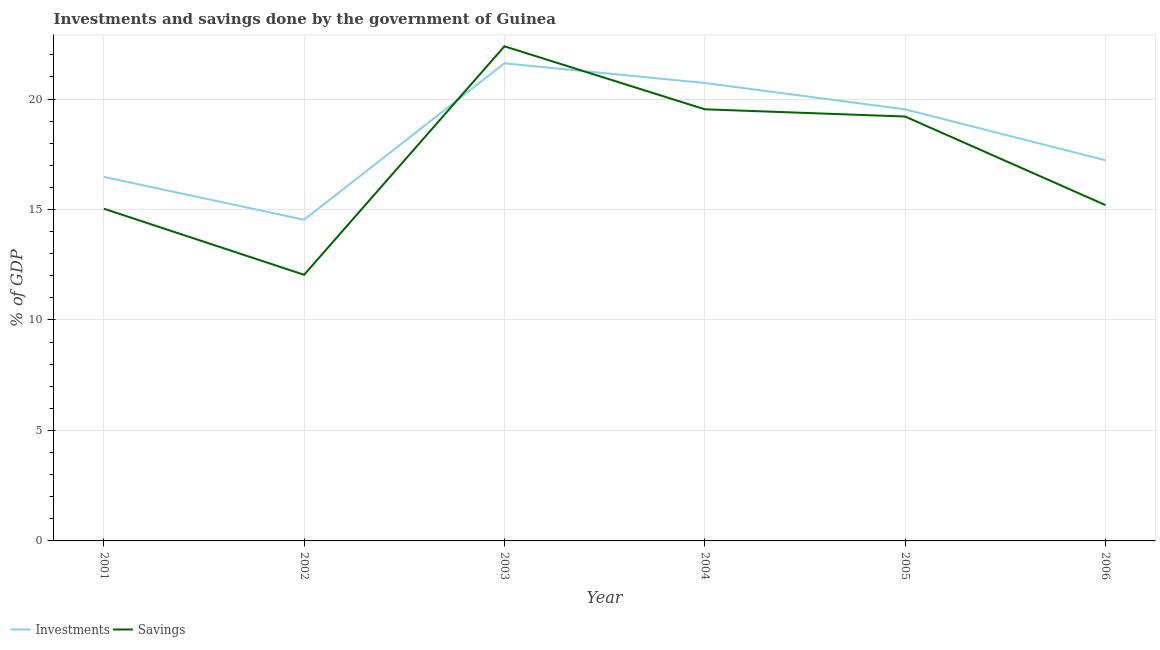How many different coloured lines are there?
Offer a very short reply. 2. What is the investments of government in 2005?
Your response must be concise. 19.53. Across all years, what is the maximum investments of government?
Make the answer very short. 21.62. Across all years, what is the minimum savings of government?
Provide a succinct answer. 12.05. In which year was the savings of government maximum?
Make the answer very short. 2003. What is the total savings of government in the graph?
Give a very brief answer. 103.42. What is the difference between the investments of government in 2001 and that in 2003?
Offer a terse response. -5.14. What is the difference between the savings of government in 2005 and the investments of government in 2003?
Your response must be concise. -2.41. What is the average savings of government per year?
Offer a very short reply. 17.24. In the year 2002, what is the difference between the investments of government and savings of government?
Offer a terse response. 2.49. What is the ratio of the savings of government in 2001 to that in 2003?
Provide a short and direct response. 0.67. Is the difference between the savings of government in 2002 and 2006 greater than the difference between the investments of government in 2002 and 2006?
Your response must be concise. No. What is the difference between the highest and the second highest investments of government?
Offer a terse response. 0.89. What is the difference between the highest and the lowest savings of government?
Ensure brevity in your answer.  10.34. In how many years, is the savings of government greater than the average savings of government taken over all years?
Your response must be concise. 3. Does the savings of government monotonically increase over the years?
Provide a succinct answer. No. What is the difference between two consecutive major ticks on the Y-axis?
Ensure brevity in your answer.  5. Are the values on the major ticks of Y-axis written in scientific E-notation?
Your answer should be compact. No. Does the graph contain any zero values?
Keep it short and to the point. No. How many legend labels are there?
Keep it short and to the point. 2. How are the legend labels stacked?
Your answer should be very brief. Horizontal. What is the title of the graph?
Ensure brevity in your answer.  Investments and savings done by the government of Guinea. Does "Forest" appear as one of the legend labels in the graph?
Provide a short and direct response. No. What is the label or title of the Y-axis?
Give a very brief answer. % of GDP. What is the % of GDP in Investments in 2001?
Give a very brief answer. 16.48. What is the % of GDP in Savings in 2001?
Provide a short and direct response. 15.04. What is the % of GDP of Investments in 2002?
Your answer should be compact. 14.54. What is the % of GDP in Savings in 2002?
Provide a short and direct response. 12.05. What is the % of GDP of Investments in 2003?
Ensure brevity in your answer.  21.62. What is the % of GDP of Savings in 2003?
Offer a very short reply. 22.39. What is the % of GDP in Investments in 2004?
Your answer should be very brief. 20.73. What is the % of GDP in Savings in 2004?
Offer a terse response. 19.54. What is the % of GDP in Investments in 2005?
Make the answer very short. 19.53. What is the % of GDP in Savings in 2005?
Make the answer very short. 19.21. What is the % of GDP of Investments in 2006?
Your answer should be very brief. 17.23. What is the % of GDP of Savings in 2006?
Provide a short and direct response. 15.2. Across all years, what is the maximum % of GDP of Investments?
Offer a terse response. 21.62. Across all years, what is the maximum % of GDP in Savings?
Keep it short and to the point. 22.39. Across all years, what is the minimum % of GDP of Investments?
Give a very brief answer. 14.54. Across all years, what is the minimum % of GDP in Savings?
Provide a succinct answer. 12.05. What is the total % of GDP in Investments in the graph?
Provide a succinct answer. 110.12. What is the total % of GDP in Savings in the graph?
Keep it short and to the point. 103.42. What is the difference between the % of GDP of Investments in 2001 and that in 2002?
Give a very brief answer. 1.94. What is the difference between the % of GDP of Savings in 2001 and that in 2002?
Ensure brevity in your answer.  2.99. What is the difference between the % of GDP of Investments in 2001 and that in 2003?
Ensure brevity in your answer.  -5.14. What is the difference between the % of GDP in Savings in 2001 and that in 2003?
Give a very brief answer. -7.35. What is the difference between the % of GDP in Investments in 2001 and that in 2004?
Your answer should be very brief. -4.25. What is the difference between the % of GDP in Savings in 2001 and that in 2004?
Keep it short and to the point. -4.5. What is the difference between the % of GDP in Investments in 2001 and that in 2005?
Keep it short and to the point. -3.06. What is the difference between the % of GDP of Savings in 2001 and that in 2005?
Your response must be concise. -4.17. What is the difference between the % of GDP in Investments in 2001 and that in 2006?
Ensure brevity in your answer.  -0.75. What is the difference between the % of GDP of Savings in 2001 and that in 2006?
Make the answer very short. -0.17. What is the difference between the % of GDP of Investments in 2002 and that in 2003?
Provide a succinct answer. -7.08. What is the difference between the % of GDP in Savings in 2002 and that in 2003?
Offer a terse response. -10.34. What is the difference between the % of GDP of Investments in 2002 and that in 2004?
Your response must be concise. -6.19. What is the difference between the % of GDP in Savings in 2002 and that in 2004?
Offer a terse response. -7.49. What is the difference between the % of GDP in Investments in 2002 and that in 2005?
Offer a very short reply. -5. What is the difference between the % of GDP of Savings in 2002 and that in 2005?
Make the answer very short. -7.16. What is the difference between the % of GDP in Investments in 2002 and that in 2006?
Keep it short and to the point. -2.69. What is the difference between the % of GDP of Savings in 2002 and that in 2006?
Provide a succinct answer. -3.16. What is the difference between the % of GDP in Investments in 2003 and that in 2004?
Offer a terse response. 0.89. What is the difference between the % of GDP in Savings in 2003 and that in 2004?
Provide a short and direct response. 2.85. What is the difference between the % of GDP in Investments in 2003 and that in 2005?
Your answer should be compact. 2.08. What is the difference between the % of GDP of Savings in 2003 and that in 2005?
Give a very brief answer. 3.18. What is the difference between the % of GDP in Investments in 2003 and that in 2006?
Your answer should be compact. 4.39. What is the difference between the % of GDP of Savings in 2003 and that in 2006?
Give a very brief answer. 7.19. What is the difference between the % of GDP of Investments in 2004 and that in 2005?
Your response must be concise. 1.19. What is the difference between the % of GDP of Savings in 2004 and that in 2005?
Ensure brevity in your answer.  0.33. What is the difference between the % of GDP of Investments in 2004 and that in 2006?
Your answer should be compact. 3.5. What is the difference between the % of GDP of Savings in 2004 and that in 2006?
Your answer should be compact. 4.33. What is the difference between the % of GDP in Investments in 2005 and that in 2006?
Keep it short and to the point. 2.31. What is the difference between the % of GDP in Savings in 2005 and that in 2006?
Provide a succinct answer. 4.01. What is the difference between the % of GDP of Investments in 2001 and the % of GDP of Savings in 2002?
Offer a terse response. 4.43. What is the difference between the % of GDP of Investments in 2001 and the % of GDP of Savings in 2003?
Your response must be concise. -5.91. What is the difference between the % of GDP in Investments in 2001 and the % of GDP in Savings in 2004?
Offer a terse response. -3.06. What is the difference between the % of GDP in Investments in 2001 and the % of GDP in Savings in 2005?
Offer a very short reply. -2.73. What is the difference between the % of GDP of Investments in 2001 and the % of GDP of Savings in 2006?
Offer a very short reply. 1.27. What is the difference between the % of GDP in Investments in 2002 and the % of GDP in Savings in 2003?
Your answer should be compact. -7.85. What is the difference between the % of GDP in Investments in 2002 and the % of GDP in Savings in 2004?
Offer a terse response. -5. What is the difference between the % of GDP in Investments in 2002 and the % of GDP in Savings in 2005?
Your response must be concise. -4.67. What is the difference between the % of GDP in Investments in 2002 and the % of GDP in Savings in 2006?
Your answer should be compact. -0.66. What is the difference between the % of GDP of Investments in 2003 and the % of GDP of Savings in 2004?
Your answer should be compact. 2.08. What is the difference between the % of GDP in Investments in 2003 and the % of GDP in Savings in 2005?
Ensure brevity in your answer.  2.41. What is the difference between the % of GDP of Investments in 2003 and the % of GDP of Savings in 2006?
Your response must be concise. 6.41. What is the difference between the % of GDP in Investments in 2004 and the % of GDP in Savings in 2005?
Your answer should be very brief. 1.52. What is the difference between the % of GDP of Investments in 2004 and the % of GDP of Savings in 2006?
Give a very brief answer. 5.52. What is the difference between the % of GDP in Investments in 2005 and the % of GDP in Savings in 2006?
Keep it short and to the point. 4.33. What is the average % of GDP of Investments per year?
Ensure brevity in your answer.  18.35. What is the average % of GDP in Savings per year?
Keep it short and to the point. 17.24. In the year 2001, what is the difference between the % of GDP in Investments and % of GDP in Savings?
Your answer should be compact. 1.44. In the year 2002, what is the difference between the % of GDP of Investments and % of GDP of Savings?
Offer a very short reply. 2.49. In the year 2003, what is the difference between the % of GDP in Investments and % of GDP in Savings?
Offer a very short reply. -0.77. In the year 2004, what is the difference between the % of GDP of Investments and % of GDP of Savings?
Offer a very short reply. 1.19. In the year 2005, what is the difference between the % of GDP of Investments and % of GDP of Savings?
Keep it short and to the point. 0.33. In the year 2006, what is the difference between the % of GDP of Investments and % of GDP of Savings?
Make the answer very short. 2.03. What is the ratio of the % of GDP of Investments in 2001 to that in 2002?
Offer a very short reply. 1.13. What is the ratio of the % of GDP in Savings in 2001 to that in 2002?
Provide a succinct answer. 1.25. What is the ratio of the % of GDP of Investments in 2001 to that in 2003?
Provide a succinct answer. 0.76. What is the ratio of the % of GDP of Savings in 2001 to that in 2003?
Ensure brevity in your answer.  0.67. What is the ratio of the % of GDP in Investments in 2001 to that in 2004?
Ensure brevity in your answer.  0.8. What is the ratio of the % of GDP of Savings in 2001 to that in 2004?
Make the answer very short. 0.77. What is the ratio of the % of GDP of Investments in 2001 to that in 2005?
Your response must be concise. 0.84. What is the ratio of the % of GDP in Savings in 2001 to that in 2005?
Provide a succinct answer. 0.78. What is the ratio of the % of GDP in Investments in 2001 to that in 2006?
Your answer should be compact. 0.96. What is the ratio of the % of GDP in Investments in 2002 to that in 2003?
Your answer should be compact. 0.67. What is the ratio of the % of GDP in Savings in 2002 to that in 2003?
Give a very brief answer. 0.54. What is the ratio of the % of GDP in Investments in 2002 to that in 2004?
Your response must be concise. 0.7. What is the ratio of the % of GDP in Savings in 2002 to that in 2004?
Your answer should be compact. 0.62. What is the ratio of the % of GDP of Investments in 2002 to that in 2005?
Give a very brief answer. 0.74. What is the ratio of the % of GDP in Savings in 2002 to that in 2005?
Give a very brief answer. 0.63. What is the ratio of the % of GDP in Investments in 2002 to that in 2006?
Ensure brevity in your answer.  0.84. What is the ratio of the % of GDP of Savings in 2002 to that in 2006?
Give a very brief answer. 0.79. What is the ratio of the % of GDP of Investments in 2003 to that in 2004?
Provide a short and direct response. 1.04. What is the ratio of the % of GDP in Savings in 2003 to that in 2004?
Keep it short and to the point. 1.15. What is the ratio of the % of GDP in Investments in 2003 to that in 2005?
Your response must be concise. 1.11. What is the ratio of the % of GDP of Savings in 2003 to that in 2005?
Your response must be concise. 1.17. What is the ratio of the % of GDP in Investments in 2003 to that in 2006?
Your answer should be compact. 1.25. What is the ratio of the % of GDP in Savings in 2003 to that in 2006?
Keep it short and to the point. 1.47. What is the ratio of the % of GDP in Investments in 2004 to that in 2005?
Ensure brevity in your answer.  1.06. What is the ratio of the % of GDP of Savings in 2004 to that in 2005?
Provide a short and direct response. 1.02. What is the ratio of the % of GDP of Investments in 2004 to that in 2006?
Offer a terse response. 1.2. What is the ratio of the % of GDP of Savings in 2004 to that in 2006?
Keep it short and to the point. 1.29. What is the ratio of the % of GDP of Investments in 2005 to that in 2006?
Your answer should be very brief. 1.13. What is the ratio of the % of GDP in Savings in 2005 to that in 2006?
Give a very brief answer. 1.26. What is the difference between the highest and the second highest % of GDP in Investments?
Your response must be concise. 0.89. What is the difference between the highest and the second highest % of GDP in Savings?
Give a very brief answer. 2.85. What is the difference between the highest and the lowest % of GDP in Investments?
Keep it short and to the point. 7.08. What is the difference between the highest and the lowest % of GDP of Savings?
Your response must be concise. 10.34. 